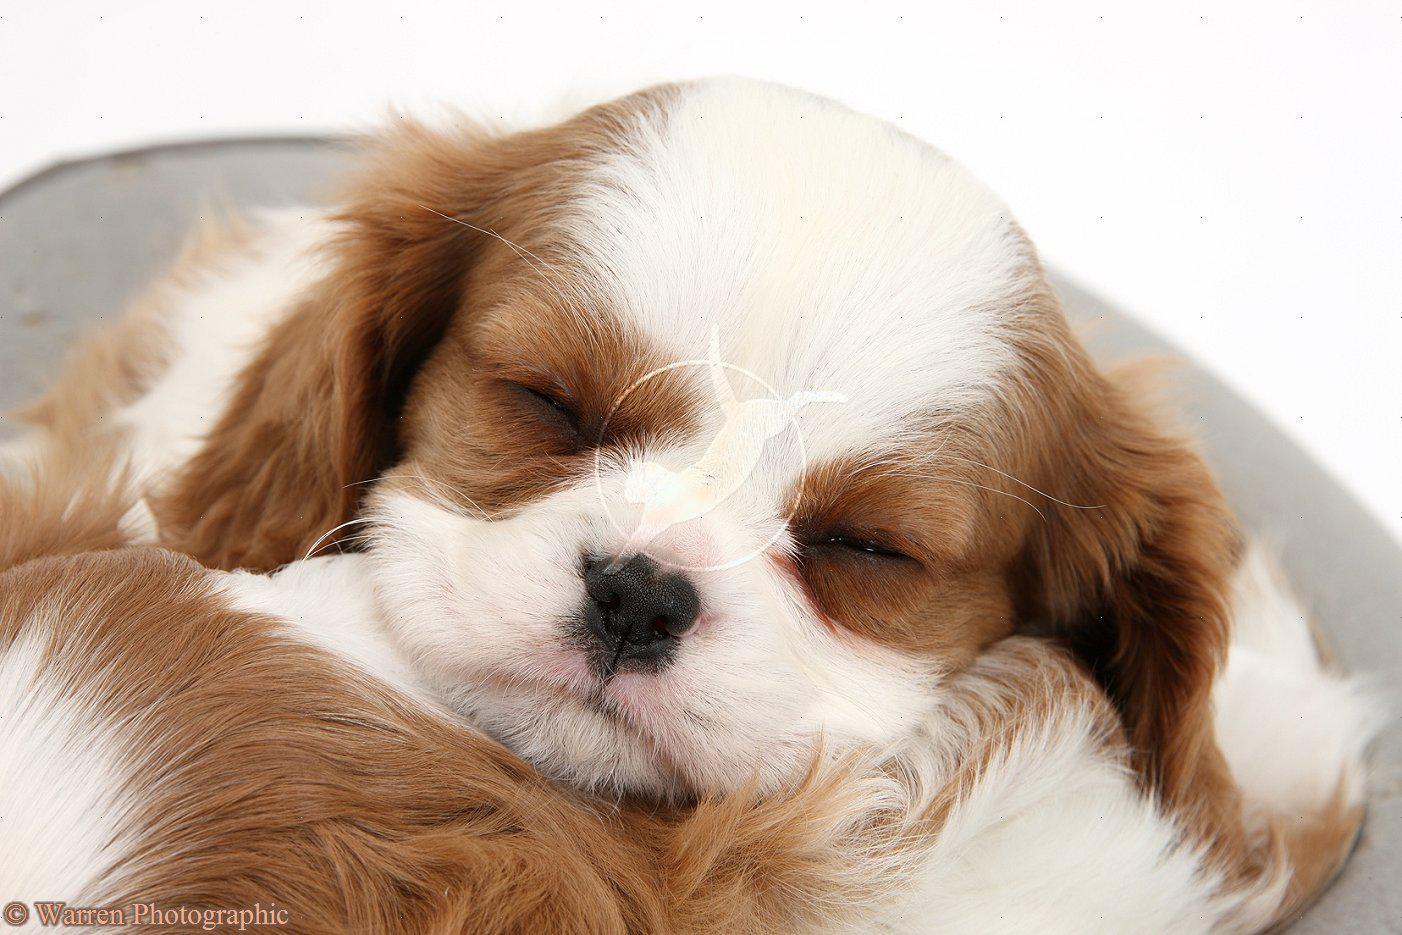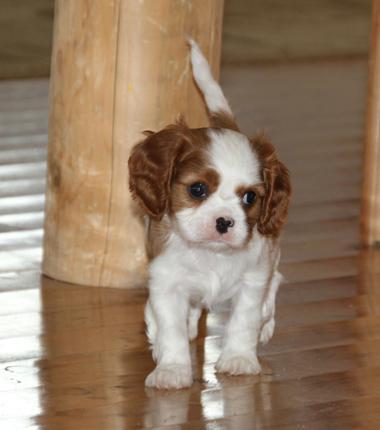The first image is the image on the left, the second image is the image on the right. Analyze the images presented: Is the assertion "A rabbit is with at least one puppy." valid? Answer yes or no. No. 